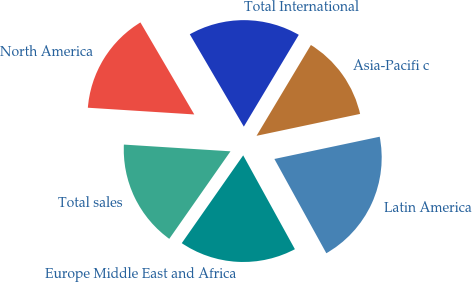Convert chart to OTSL. <chart><loc_0><loc_0><loc_500><loc_500><pie_chart><fcel>Europe Middle East and Africa<fcel>Latin America<fcel>Asia-Pacifi c<fcel>Total International<fcel>North America<fcel>Total sales<nl><fcel>17.73%<fcel>20.3%<fcel>13.1%<fcel>17.01%<fcel>15.57%<fcel>16.29%<nl></chart> 